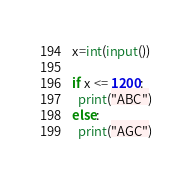Convert code to text. <code><loc_0><loc_0><loc_500><loc_500><_Python_>x=int(input())

if x <= 1200:
  print("ABC")
else:
  print("AGC")</code> 